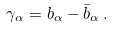Convert formula to latex. <formula><loc_0><loc_0><loc_500><loc_500>\gamma _ { \alpha } = b _ { \alpha } - \bar { b } _ { \alpha } \, .</formula> 